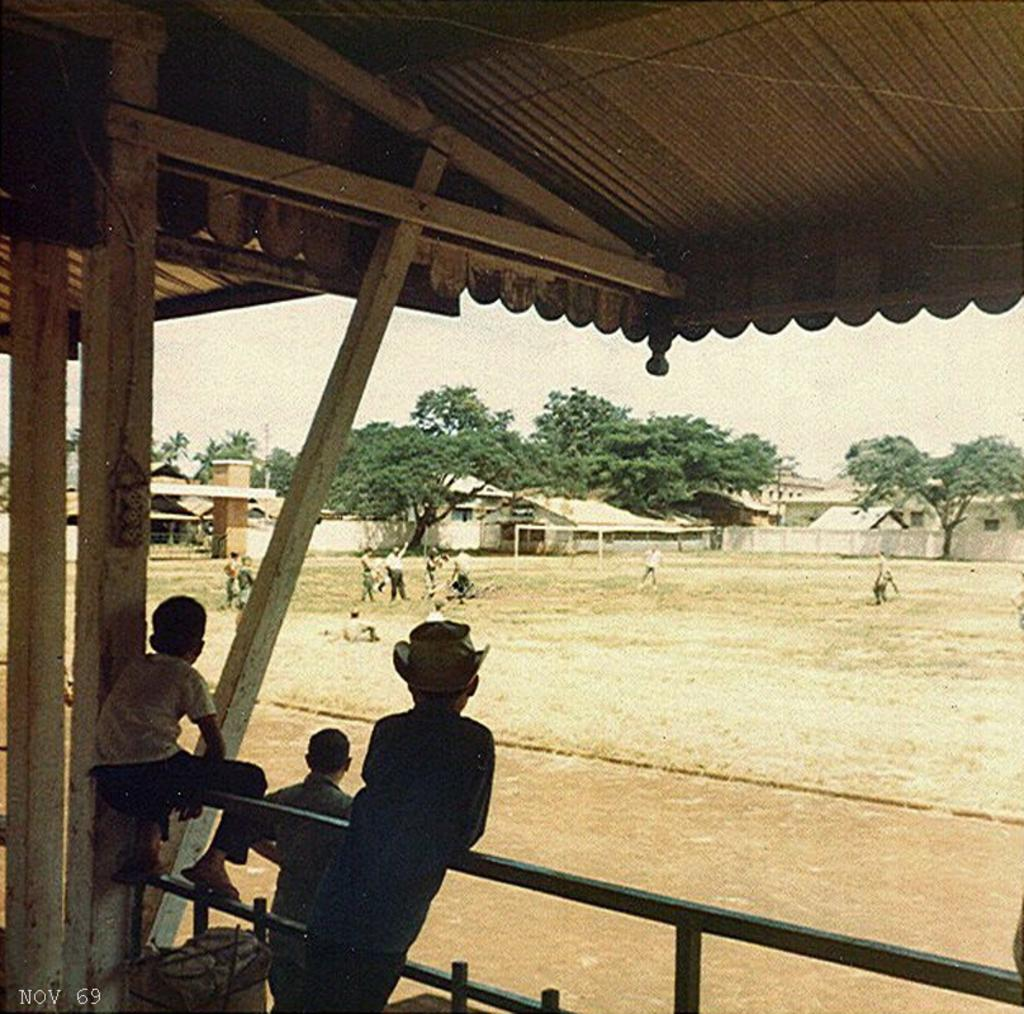What are the persons in the image doing? The persons in the image are standing on the railing and the ground. What type of vegetation can be seen in the image? There are trees in the image. What type of structure is present in the image? There is a shed in the image. What is the background of the image? There are walls in the image, and the sky is visible. What type of noise can be heard coming from the railway in the image? There is no railway present in the image, so it's not possible to determine what, if any, noise might be heard. 